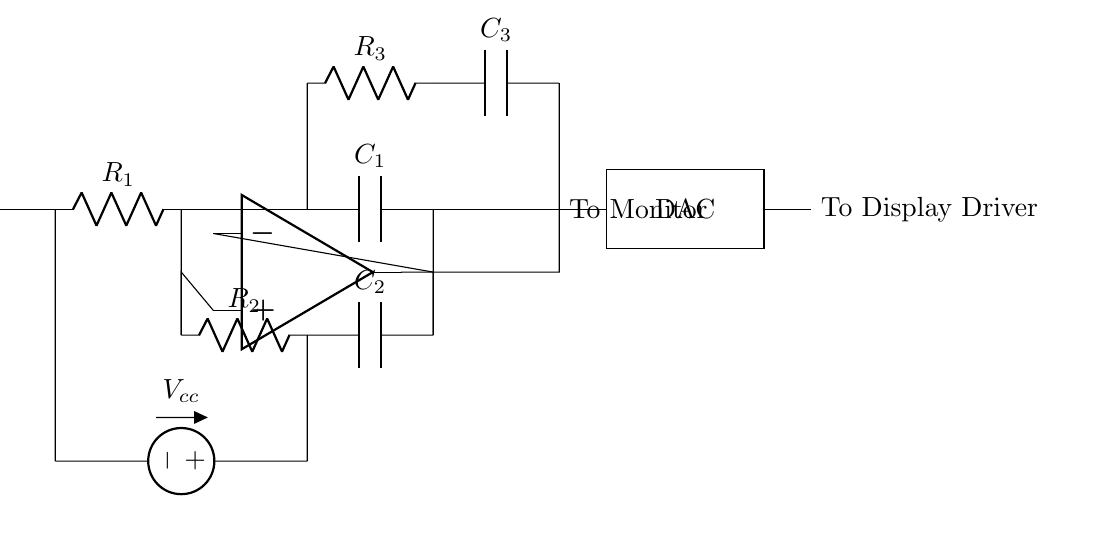What is the input voltage supply in the circuit? The input voltage supply, labeled as Vcc, is located at the left side of the circuit and indicates the positive voltage supplied to the circuit.
Answer: Vcc How many resistors are there in this circuit? The circuit diagram shows a total of three resistors, denoted as R1, R2, and R3. These components are crucial for controlling the current flow in different sections of the circuit.
Answer: 3 What is the function of the op-amp in this circuit? The op-amp serves as a signal amplifier, taking the difference between the voltage at the non-inverting input and the inverting input, which aids in generating the output voltage sent to the monitor.
Answer: Amplification What type of components are C1, C2, and C3? The components C1, C2, and C3 are capacitors, which are used for filtering or stabilizing voltage fluctuations in the circuit by storing and releasing electrical energy.
Answer: Capacitors What is the output of the DAC connected to? The output of the DAC is connected to the display driver, helping to translate the digital signal from the DAC into a format suitable for driving the monitor.
Answer: Display Driver How does the arrangement of resistors and capacitors affect performance? The arrangement of resistors and capacitors in the circuit determines the timing characteristics of the circuit, influencing how quickly the circuit can respond to input changes, thereby affecting refresh rate and smoothness in animations.
Answer: Timing characteristics What does the label "To Monitor" signify in the circuit? The label "To Monitor" indicates where the processed signal from the circuit is sent, informing us that the output is intended for a high-refresh-rate monitor to enable smooth visuals.
Answer: Processed signal output 